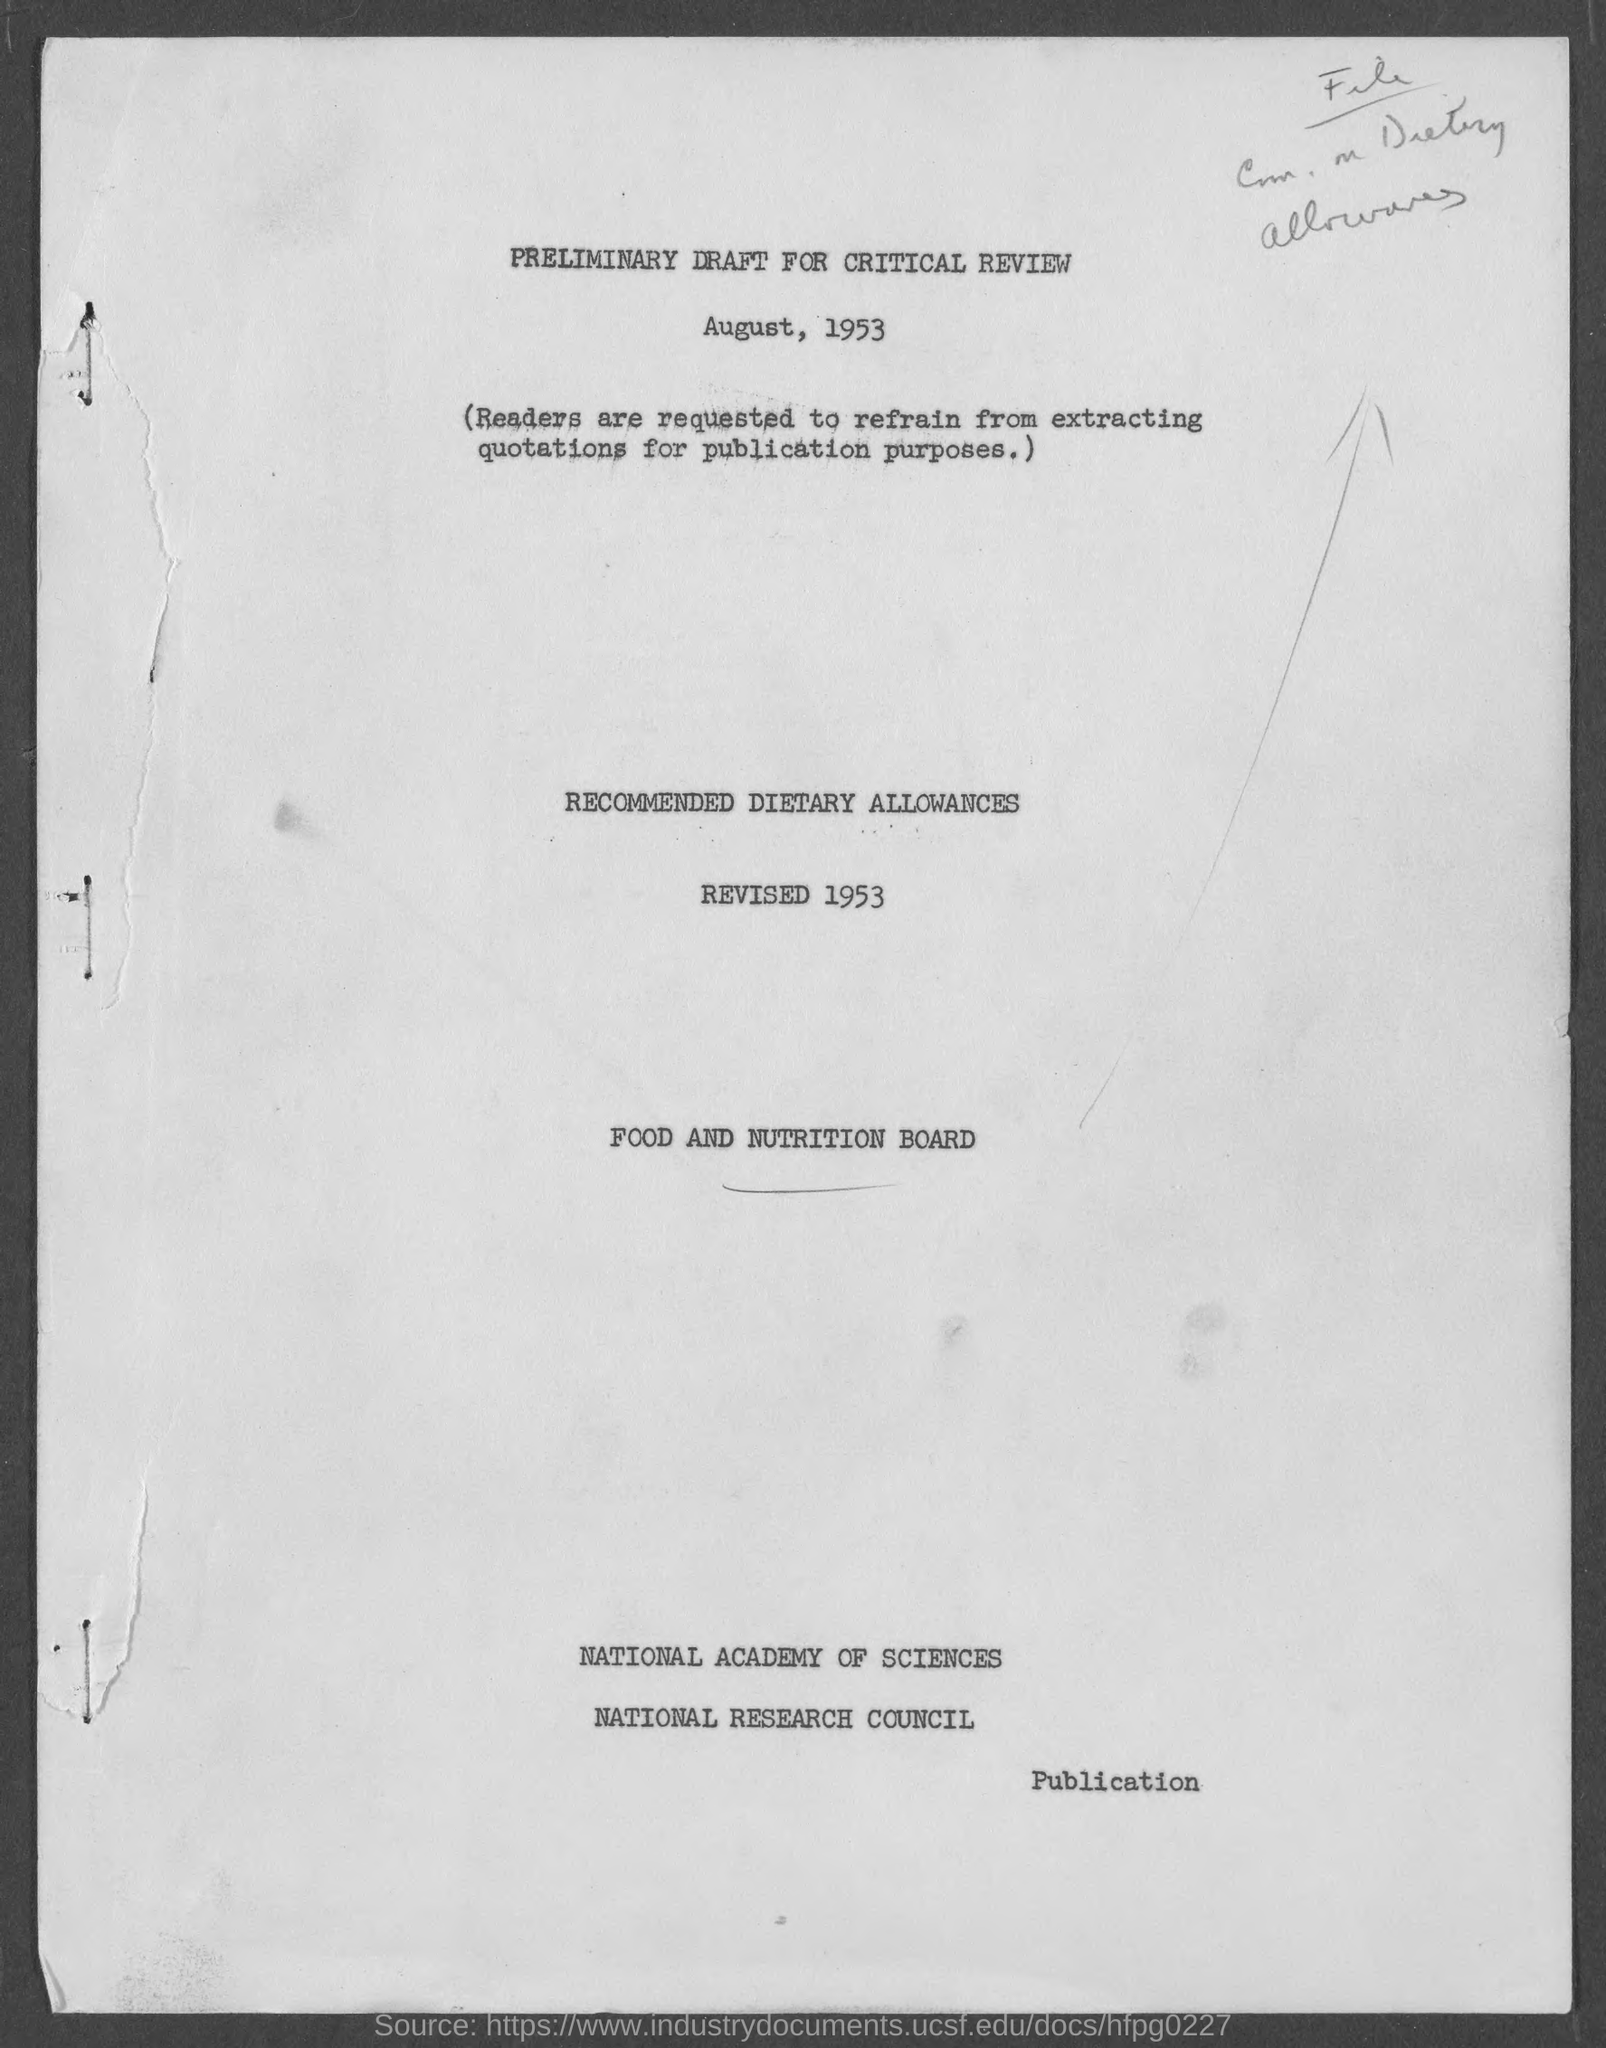Give some essential details in this illustration. The preliminary draft for critical review was mentioned on August, 1953. 